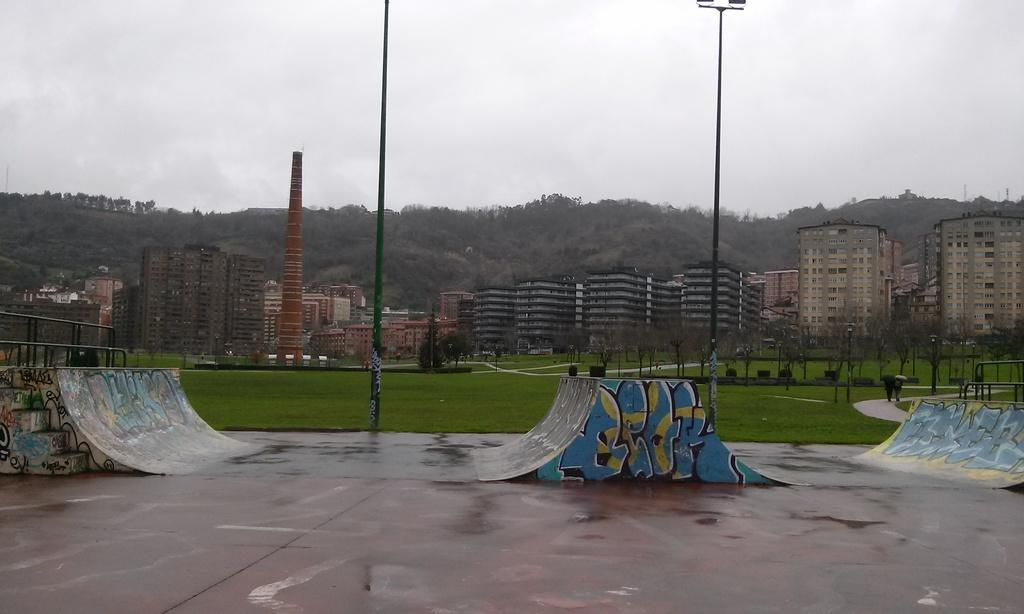What type of structures can be seen in the image? There are buildings in the image. What natural elements are present in the image? There are trees and grassland in the image. What man-made objects can be seen in the image? There are painted boards in the image. What color is the father's thought in the image? There is no mention of a father or a thought in the image; the facts provided only mention buildings, trees, grassland, and painted boards. 